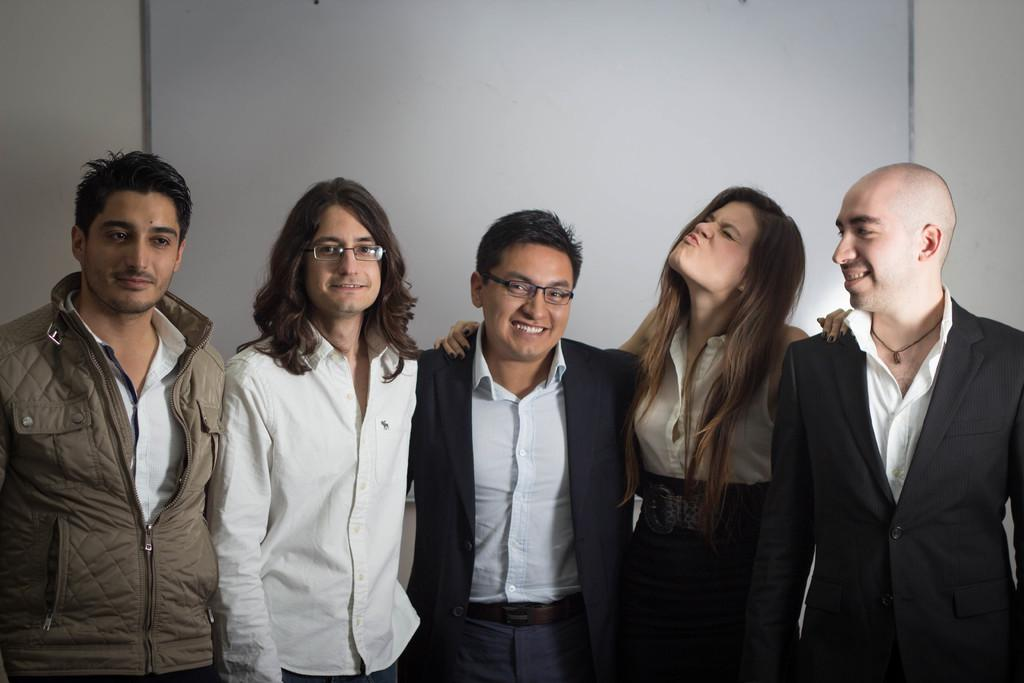How many people are in the image? There is a group of people in the image. What are the people in the image doing? The people are standing together and smiling. What can be seen in the background of the image? There is a board on a wall in the background of the image. What type of toy is the uncle holding in the image? There is no uncle or toy present in the image. 